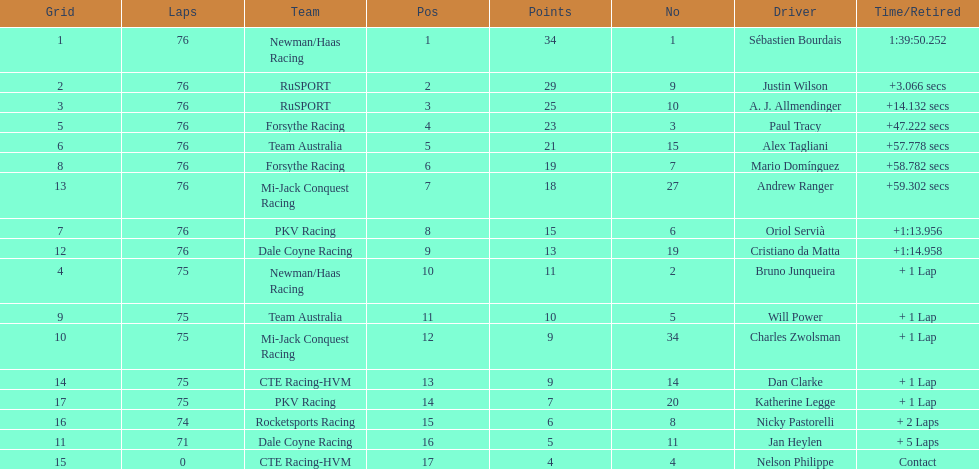Which canadian driver finished first: alex tagliani or paul tracy? Paul Tracy. 